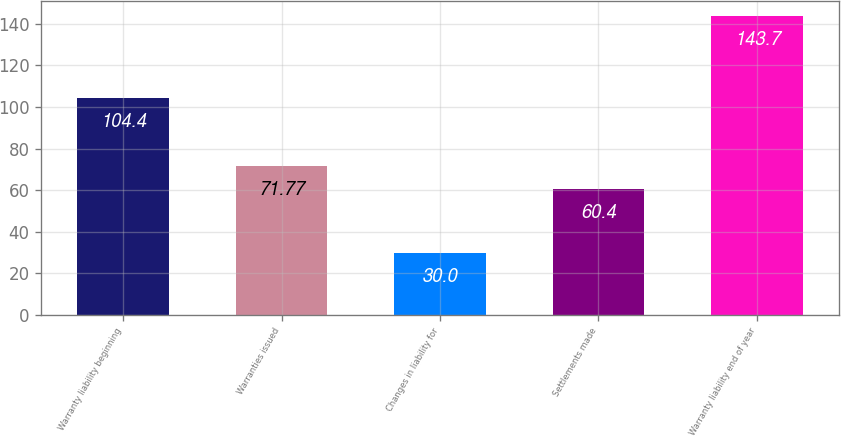Convert chart. <chart><loc_0><loc_0><loc_500><loc_500><bar_chart><fcel>Warranty liability beginning<fcel>Warranties issued<fcel>Changes in liability for<fcel>Settlements made<fcel>Warranty liability end of year<nl><fcel>104.4<fcel>71.77<fcel>30<fcel>60.4<fcel>143.7<nl></chart> 